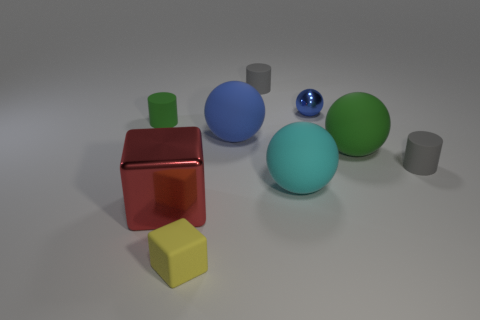Subtract all cyan matte spheres. How many spheres are left? 3 Subtract all brown cylinders. How many blue spheres are left? 2 Subtract 2 balls. How many balls are left? 2 Subtract all green balls. How many balls are left? 3 Subtract all balls. How many objects are left? 5 Subtract all purple metallic objects. Subtract all cyan objects. How many objects are left? 8 Add 2 cyan objects. How many cyan objects are left? 3 Add 4 metallic blocks. How many metallic blocks exist? 5 Subtract 0 cyan cubes. How many objects are left? 9 Subtract all red cubes. Subtract all blue cylinders. How many cubes are left? 1 